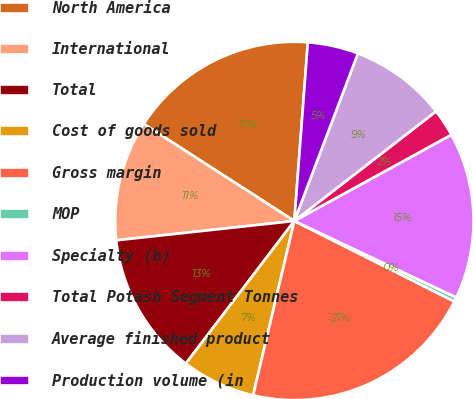Convert chart. <chart><loc_0><loc_0><loc_500><loc_500><pie_chart><fcel>North America<fcel>International<fcel>Total<fcel>Cost of goods sold<fcel>Gross margin<fcel>MOP<fcel>Specialty (b)<fcel>Total Potash Segment Tonnes<fcel>Average finished product<fcel>Production volume (in<nl><fcel>17.09%<fcel>10.83%<fcel>12.92%<fcel>6.66%<fcel>21.27%<fcel>0.4%<fcel>15.01%<fcel>2.49%<fcel>8.75%<fcel>4.57%<nl></chart> 